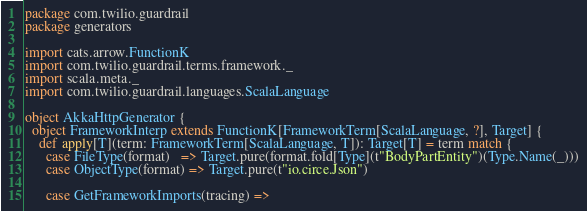Convert code to text. <code><loc_0><loc_0><loc_500><loc_500><_Scala_>package com.twilio.guardrail
package generators

import cats.arrow.FunctionK
import com.twilio.guardrail.terms.framework._
import scala.meta._
import com.twilio.guardrail.languages.ScalaLanguage

object AkkaHttpGenerator {
  object FrameworkInterp extends FunctionK[FrameworkTerm[ScalaLanguage, ?], Target] {
    def apply[T](term: FrameworkTerm[ScalaLanguage, T]): Target[T] = term match {
      case FileType(format)   => Target.pure(format.fold[Type](t"BodyPartEntity")(Type.Name(_)))
      case ObjectType(format) => Target.pure(t"io.circe.Json")

      case GetFrameworkImports(tracing) =></code> 